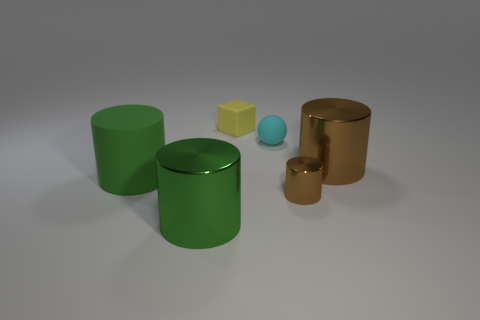There is a small thing that is in front of the small ball; is it the same color as the large shiny thing to the right of the tiny yellow rubber object?
Offer a terse response. Yes. There is a tiny rubber sphere that is to the left of the large shiny thing to the right of the cyan rubber ball; how many tiny rubber balls are in front of it?
Make the answer very short. 0. How many rubber objects are left of the small cube and right of the big matte object?
Provide a succinct answer. 0. Are there more tiny yellow blocks that are on the left side of the large brown metal cylinder than large gray metallic cylinders?
Offer a terse response. Yes. How many cyan metal balls are the same size as the yellow rubber cube?
Make the answer very short. 0. How many small things are yellow metallic cubes or cyan matte objects?
Offer a terse response. 1. What number of brown shiny cylinders are there?
Your response must be concise. 2. Are there an equal number of matte cylinders behind the big brown object and big shiny cylinders that are on the left side of the small yellow rubber thing?
Offer a very short reply. No. Are there any yellow rubber things to the right of the tiny yellow cube?
Your response must be concise. No. There is a small object in front of the large brown shiny cylinder; what is its color?
Provide a succinct answer. Brown. 